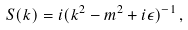<formula> <loc_0><loc_0><loc_500><loc_500>S ( k ) = i ( k ^ { 2 } - m ^ { 2 } + i \epsilon ) ^ { - 1 } \, ,</formula> 